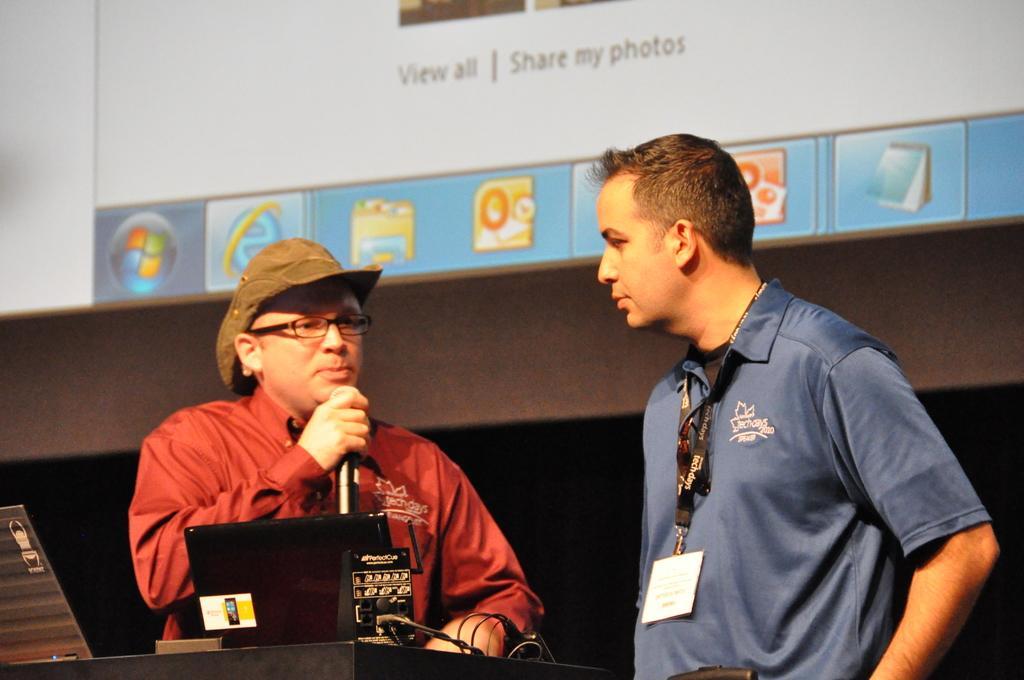Describe this image in one or two sentences. In this image we can see men standing and one of them is holding a mic in the hands and a table is placed in front of them. On the table we can see laptop and cables. In the background there is a display screen. 